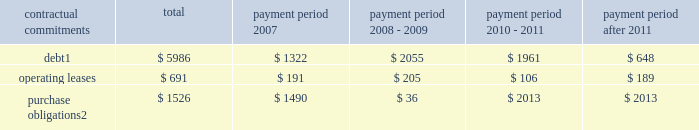Part ii , item 7 in 2006 , cash provided by financing activities was $ 291 million which was primarily due to the proceeds from employee stock plans ( $ 442 million ) and an increase in debt of $ 1.5 billion partially offset by the repurchase of 17.99 million shares of schlumberger stock ( $ 1.07 billion ) and the payment of dividends to shareholders ( $ 568 million ) .
Schlumberger believes that at december 31 , 2006 , cash and short-term investments of $ 3.0 billion and available and unused credit facilities of $ 2.2 billion are sufficient to meet future business requirements for at least the next twelve months .
Summary of major contractual commitments ( stated in millions ) .
Purchase obligations 2 $ 1526 $ 1490 $ 36 $ 2013 $ 2013 1 .
Excludes future payments for interest .
Includes amounts relating to the $ 1425 million of convertible debentures which are described in note 11 of the consolidated financial statements .
Represents an estimate of contractual obligations in the ordinary course of business .
Although these contractual obligations are considered enforceable and legally binding , the terms generally allow schlumberger the option to reschedule and adjust their requirements based on business needs prior to the delivery of goods .
Refer to note 4 of the consolidated financial statements for details regarding potential commitments associated with schlumberger 2019s prior business acquisitions .
Refer to note 20 of the consolidated financial statements for details regarding schlumberger 2019s pension and other postretirement benefit obligations .
Schlumberger has outstanding letters of credit/guarantees which relate to business performance bonds , custom/excise tax commitments , facility lease/rental obligations , etc .
These were entered into in the ordinary course of business and are customary practices in the various countries where schlumberger operates .
Critical accounting policies and estimates the preparation of financial statements and related disclosures in conformity with accounting principles generally accepted in the united states requires schlumberger to make estimates and assumptions that affect the reported amounts of assets and liabilities , the disclosure of contingent assets and liabilities and the reported amounts of revenue and expenses .
The following accounting policies involve 201ccritical accounting estimates 201d because they are particularly dependent on estimates and assumptions made by schlumberger about matters that are inherently uncertain .
A summary of all of schlumberger 2019s significant accounting policies is included in note 2 to the consolidated financial statements .
Schlumberger bases its estimates on historical experience and on various other assumptions that are believed to be reasonable under the circumstances , the results of which form the basis for making judgments about the carrying values of assets and liabilities that are not readily apparent from other sources .
Actual results may differ from these estimates under different assumptions or conditions .
Multiclient seismic data the westerngeco segment capitalizes the costs associated with obtaining multiclient seismic data .
The carrying value of the multiclient seismic data library at december 31 , 2006 , 2005 and 2004 was $ 227 million , $ 222 million and $ 347 million , respectively .
Such costs are charged to cost of goods sold and services based on the percentage of the total costs to the estimated total revenue that schlumberger expects to receive from the sales of such data .
However , except as described below under 201cwesterngeco purchase accounting , 201d under no circumstance will an individual survey carry a net book value greater than a 4-year straight-lined amortized value. .
What percentage of debt repayment will take place during 2008-2009? 
Computations: (2055 / 5986)
Answer: 0.3433. 